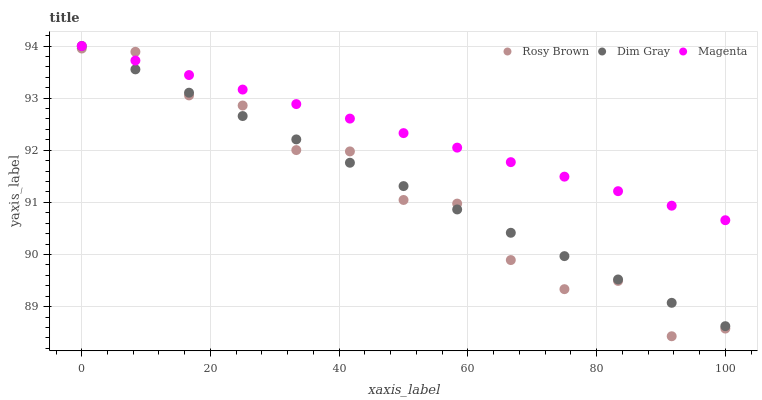Does Rosy Brown have the minimum area under the curve?
Answer yes or no. Yes. Does Magenta have the maximum area under the curve?
Answer yes or no. Yes. Does Magenta have the minimum area under the curve?
Answer yes or no. No. Does Rosy Brown have the maximum area under the curve?
Answer yes or no. No. Is Dim Gray the smoothest?
Answer yes or no. Yes. Is Rosy Brown the roughest?
Answer yes or no. Yes. Is Magenta the smoothest?
Answer yes or no. No. Is Magenta the roughest?
Answer yes or no. No. Does Rosy Brown have the lowest value?
Answer yes or no. Yes. Does Magenta have the lowest value?
Answer yes or no. No. Does Magenta have the highest value?
Answer yes or no. Yes. Does Rosy Brown have the highest value?
Answer yes or no. No. Does Magenta intersect Rosy Brown?
Answer yes or no. Yes. Is Magenta less than Rosy Brown?
Answer yes or no. No. Is Magenta greater than Rosy Brown?
Answer yes or no. No. 